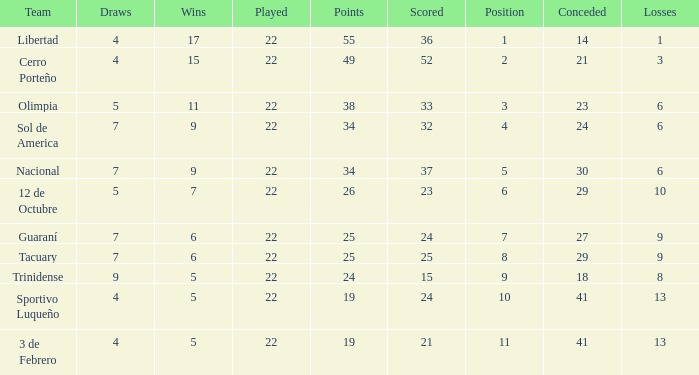What was the number of losses when the scored value was 25? 9.0. 